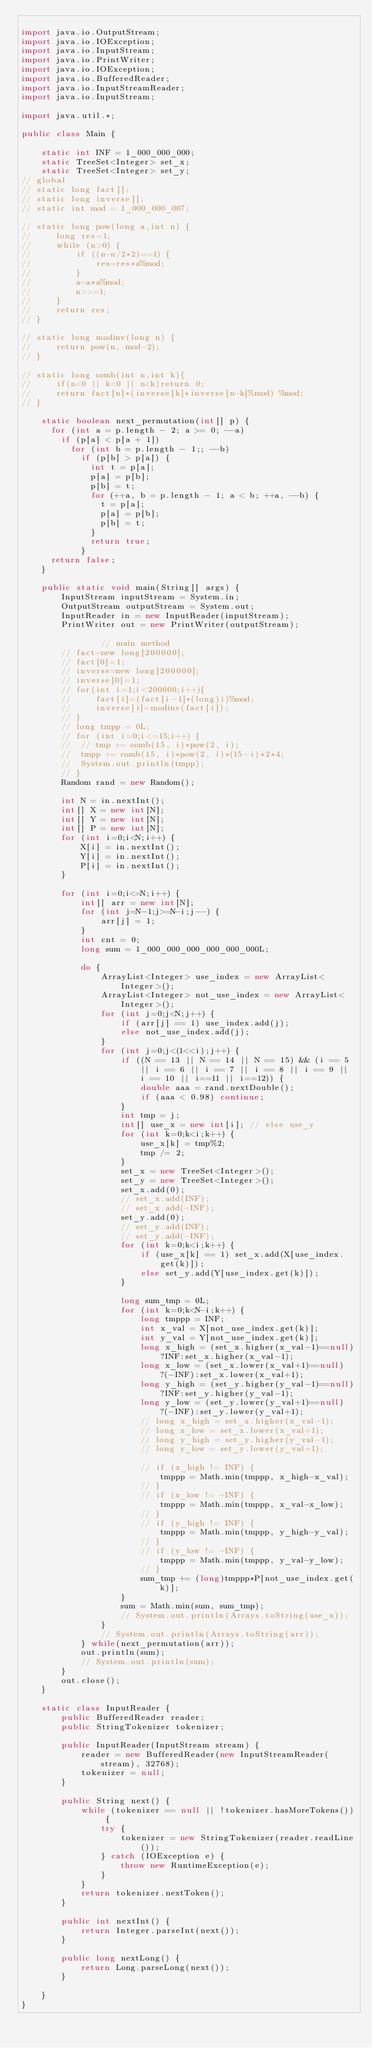Convert code to text. <code><loc_0><loc_0><loc_500><loc_500><_Java_>
import java.io.OutputStream;
import java.io.IOException;
import java.io.InputStream;
import java.io.PrintWriter;
import java.io.IOException;
import java.io.BufferedReader;
import java.io.InputStreamReader;
import java.io.InputStream;

import java.util.*;

public class Main {

	static int INF = 1_000_000_000;
	static TreeSet<Integer> set_x;
	static TreeSet<Integer> set_y;
// global
// static long fact[];
// static long inverse[];
// static int mod = 1_000_000_007;

// static long pow(long a,int n) {
//     long res=1;
//     while (n>0) {
//         if ((n-n/2*2)==1) {
//             res=res*a%mod;
//         }
//         a=a*a%mod;
//         n>>=1;
//     }
//     return res;
// }

// static long modinv(long n) {
//     return pow(n, mod-2);
// }

// static long comb(int n,int k){
//     if(n<0 || k<0 || n<k)return 0;
//     return fact[n]*(inverse[k]*inverse[n-k]%mod) %mod;
// }

	static boolean next_permutation(int[] p) {
	  for (int a = p.length - 2; a >= 0; --a)
	    if (p[a] < p[a + 1])
	      for (int b = p.length - 1;; --b)
	        if (p[b] > p[a]) {
	          int t = p[a];
	          p[a] = p[b];
	          p[b] = t;
	          for (++a, b = p.length - 1; a < b; ++a, --b) {
	            t = p[a];
	            p[a] = p[b];
	            p[b] = t;
	          }
	          return true;
	        }
	  return false;
	}

	public static void main(String[] args) {
		InputStream inputStream = System.in;
        OutputStream outputStream = System.out;
        InputReader in = new InputReader(inputStream);
        PrintWriter out = new PrintWriter(outputStream);

				// main method
		// fact=new long[200000];
		// fact[0]=1;
		// inverse=new long[200000];
		// inverse[0]=1;
		// for(int i=1;i<200000;i++){
		//     fact[i]=(fact[i-1]*(long)i)%mod;
		//     inverse[i]=modinv(fact[i]);
		// }
		// long tmpp = 0L;
		// for (int i=0;i<=15;i++) {
		// 	// tmp += comb(15, i)*pow(2, i);
		// 	tmpp += comb(15, i)*pow(2, i)*(15-i)*2*4;
		// 	System.out.println(tmpp);
		// }
		Random rand = new Random();

		int N = in.nextInt();
		int[] X = new int[N];
		int[] Y = new int[N];
		int[] P = new int[N];
		for (int i=0;i<N;i++) {
			X[i] = in.nextInt();
			Y[i] = in.nextInt();
			P[i] = in.nextInt();
		}

		for (int i=0;i<=N;i++) {
			int[] arr = new int[N];
			for (int j=N-1;j>=N-i;j--) {
				arr[j] = 1;
			}
			int cnt = 0;
			long sum = 1_000_000_000_000_000_000L;

			do {
				ArrayList<Integer> use_index = new ArrayList<Integer>();
				ArrayList<Integer> not_use_index = new ArrayList<Integer>();
				for (int j=0;j<N;j++) {
					if (arr[j] == 1) use_index.add(j);
					else not_use_index.add(j);
				}
				for (int j=0;j<(1<<i);j++) {
					if ((N == 13 || N == 14 || N == 15) && (i == 5 || i == 6 || i == 7 || i == 8 || i == 9 || i == 10 || i==11 || i==12)) {
						double aaa = rand.nextDouble();
						if (aaa < 0.98) continue;
					}
					int tmp = j;
					int[] use_x = new int[i]; // else use_y
					for (int k=0;k<i;k++) {
						use_x[k] = tmp%2;
						tmp /= 2;
					}
					set_x = new TreeSet<Integer>();
					set_y = new TreeSet<Integer>();
					set_x.add(0);
					// set_x.add(INF);
					// set_x.add(-INF);
					set_y.add(0);
					// set_y.add(INF);
					// set_y.add(-INF);
					for (int k=0;k<i;k++) {
						if (use_x[k] == 1) set_x.add(X[use_index.get(k)]);
						else set_y.add(Y[use_index.get(k)]);
					}

					long sum_tmp = 0L;
					for (int k=0;k<N-i;k++) {
						long tmppp = INF;
						int x_val = X[not_use_index.get(k)];
						int y_val = Y[not_use_index.get(k)];
						long x_high = (set_x.higher(x_val-1)==null)?INF:set_x.higher(x_val-1);
						long x_low = (set_x.lower(x_val+1)==null)?(-INF):set_x.lower(x_val+1);
						long y_high = (set_y.higher(y_val-1)==null)?INF:set_y.higher(y_val-1);
						long y_low = (set_y.lower(y_val+1)==null)?(-INF):set_y.lower(y_val+1);
						// long x_high = set_x.higher(x_val-1);
						// long x_low = set_x.lower(x_val+1);
						// long y_high = set_y.higher(y_val-1);
						// long y_low = set_y.lower(y_val+1);

						// if (x_high != INF) {
							tmppp = Math.min(tmppp, x_high-x_val);
						// }
						// if (x_low != -INF) {
							tmppp = Math.min(tmppp, x_val-x_low);
						// }
						// if (y_high != INF) {
							tmppp = Math.min(tmppp, y_high-y_val);
						// }
						// if (y_low != -INF) {
							tmppp = Math.min(tmppp, y_val-y_low);
						// }
						sum_tmp += (long)tmppp*P[not_use_index.get(k)];
					}
					sum = Math.min(sum, sum_tmp);
					// System.out.println(Arrays.toString(use_x));
				}
		    	// System.out.println(Arrays.toString(arr));
			} while(next_permutation(arr));
			out.println(sum);
			// System.out.println(sum);
		}
		out.close();
	}

	static class InputReader {
        public BufferedReader reader;
        public StringTokenizer tokenizer;

        public InputReader(InputStream stream) {
            reader = new BufferedReader(new InputStreamReader(stream), 32768);
            tokenizer = null;
        }

        public String next() {
            while (tokenizer == null || !tokenizer.hasMoreTokens()) {
                try {
                    tokenizer = new StringTokenizer(reader.readLine());
                } catch (IOException e) {
                    throw new RuntimeException(e);
                }
            }
            return tokenizer.nextToken();
        }

        public int nextInt() {
            return Integer.parseInt(next());
        }

        public long nextLong() {
            return Long.parseLong(next());
        }

    }
}</code> 